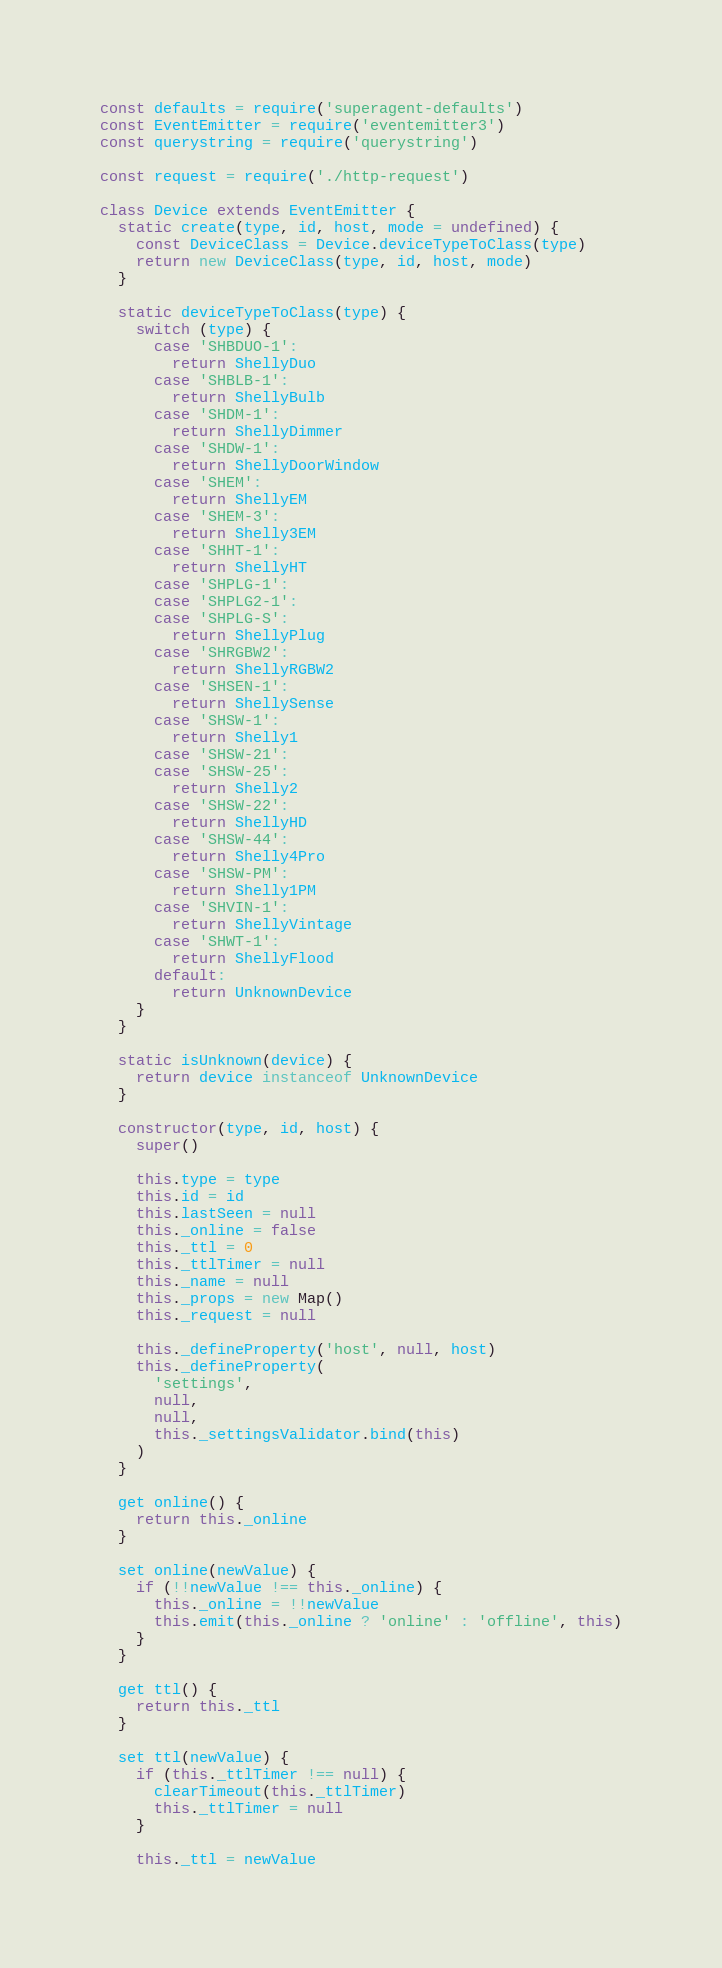Convert code to text. <code><loc_0><loc_0><loc_500><loc_500><_JavaScript_>const defaults = require('superagent-defaults')
const EventEmitter = require('eventemitter3')
const querystring = require('querystring')

const request = require('./http-request')

class Device extends EventEmitter {
  static create(type, id, host, mode = undefined) {
    const DeviceClass = Device.deviceTypeToClass(type)
    return new DeviceClass(type, id, host, mode)
  }

  static deviceTypeToClass(type) {
    switch (type) {
      case 'SHBDUO-1':
        return ShellyDuo
      case 'SHBLB-1':
        return ShellyBulb
      case 'SHDM-1':
        return ShellyDimmer
      case 'SHDW-1':
        return ShellyDoorWindow
      case 'SHEM':
        return ShellyEM
      case 'SHEM-3':
        return Shelly3EM
      case 'SHHT-1':
        return ShellyHT
      case 'SHPLG-1':
      case 'SHPLG2-1':
      case 'SHPLG-S':
        return ShellyPlug
      case 'SHRGBW2':
        return ShellyRGBW2
      case 'SHSEN-1':
        return ShellySense
      case 'SHSW-1':
        return Shelly1
      case 'SHSW-21':
      case 'SHSW-25':
        return Shelly2
      case 'SHSW-22':
        return ShellyHD
      case 'SHSW-44':
        return Shelly4Pro
      case 'SHSW-PM':
        return Shelly1PM
      case 'SHVIN-1':
        return ShellyVintage
      case 'SHWT-1':
        return ShellyFlood
      default:
        return UnknownDevice
    }
  }

  static isUnknown(device) {
    return device instanceof UnknownDevice
  }

  constructor(type, id, host) {
    super()

    this.type = type
    this.id = id
    this.lastSeen = null
    this._online = false
    this._ttl = 0
    this._ttlTimer = null
    this._name = null
    this._props = new Map()
    this._request = null

    this._defineProperty('host', null, host)
    this._defineProperty(
      'settings',
      null,
      null,
      this._settingsValidator.bind(this)
    )
  }

  get online() {
    return this._online
  }

  set online(newValue) {
    if (!!newValue !== this._online) {
      this._online = !!newValue
      this.emit(this._online ? 'online' : 'offline', this)
    }
  }

  get ttl() {
    return this._ttl
  }

  set ttl(newValue) {
    if (this._ttlTimer !== null) {
      clearTimeout(this._ttlTimer)
      this._ttlTimer = null
    }

    this._ttl = newValue
</code> 